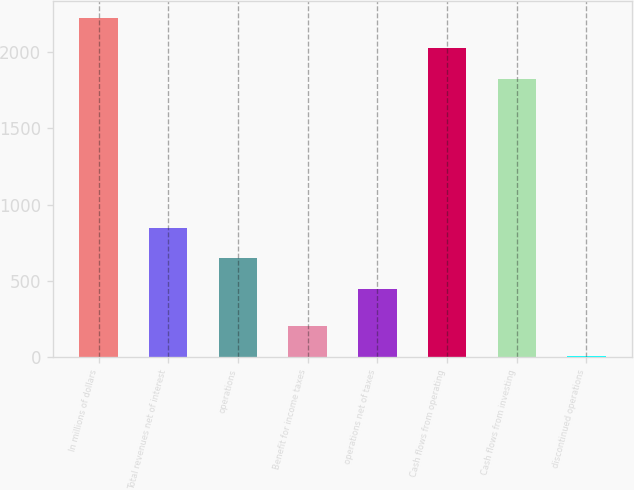Convert chart. <chart><loc_0><loc_0><loc_500><loc_500><bar_chart><fcel>In millions of dollars<fcel>Total revenues net of interest<fcel>operations<fcel>Benefit for income taxes<fcel>operations net of taxes<fcel>Cash flows from operating<fcel>Cash flows from investing<fcel>discontinued operations<nl><fcel>2224.6<fcel>848.6<fcel>648.3<fcel>206.3<fcel>448<fcel>2024.3<fcel>1824<fcel>6<nl></chart> 